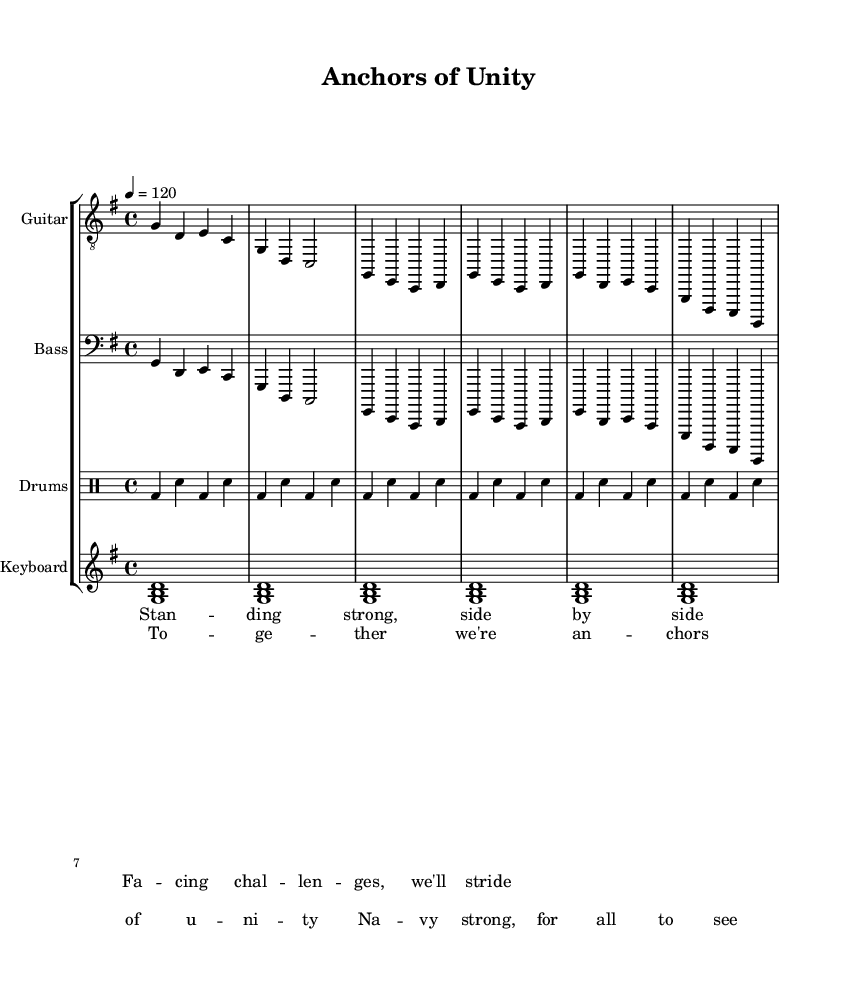What is the key signature of this music? The key signature indicated is G major, which has one sharp (F#). This can be determined from the global declaration in the code.
Answer: G major What is the time signature of this music? The time signature shown is 4/4, as stated in the global settings of the code. This means there are four beats per measure, and each quarter note receives one beat.
Answer: 4/4 What is the tempo marking for the music? The tempo marking is 120 beats per minute, as specified in the global section. This indicates the speed at which the piece should be played.
Answer: 120 What is the first lyric of the verse? The first lyric of the verse is "Standing strong, side by side," as it is extracted from the verseWords section where the lyrics are defined.
Answer: Standing strong, side by side Which instruments are involved in the music? The instruments included in the score are Guitar, Bass, Drums, and Keyboard, as defined in the StaffGroup section of the code.
Answer: Guitar, Bass, Drums, Keyboard How many measures are in the chorus? The chorus contains two measures, as evidenced in the chorusWords section, where the lyrics span two lines corresponding to two measures.
Answer: 2 What theme do the lyrics convey? The lyrics convey themes of teamwork and unity, which can be inferred from phrases like "together we're anchors of unity." This reflects camaraderie and support among individuals.
Answer: Teamwork and unity 